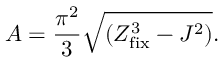Convert formula to latex. <formula><loc_0><loc_0><loc_500><loc_500>A = { \frac { \pi ^ { 2 } } { 3 } } \sqrt { ( Z _ { f i x } ^ { 3 } - J ^ { 2 } ) } .</formula> 